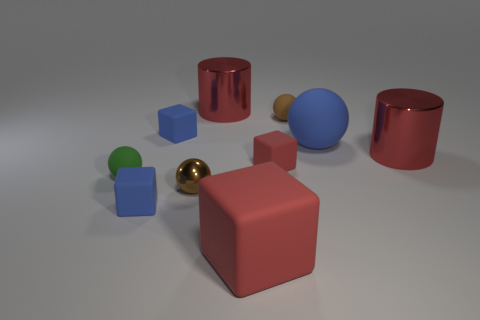Subtract all blocks. How many objects are left? 6 Subtract all blue rubber balls. Subtract all blue balls. How many objects are left? 8 Add 4 tiny green objects. How many tiny green objects are left? 5 Add 6 blue rubber things. How many blue rubber things exist? 9 Subtract 0 yellow cubes. How many objects are left? 10 